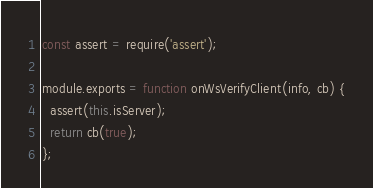Convert code to text. <code><loc_0><loc_0><loc_500><loc_500><_JavaScript_>const assert = require('assert');

module.exports = function onWsVerifyClient(info, cb) {
  assert(this.isServer);
  return cb(true);
};
</code> 